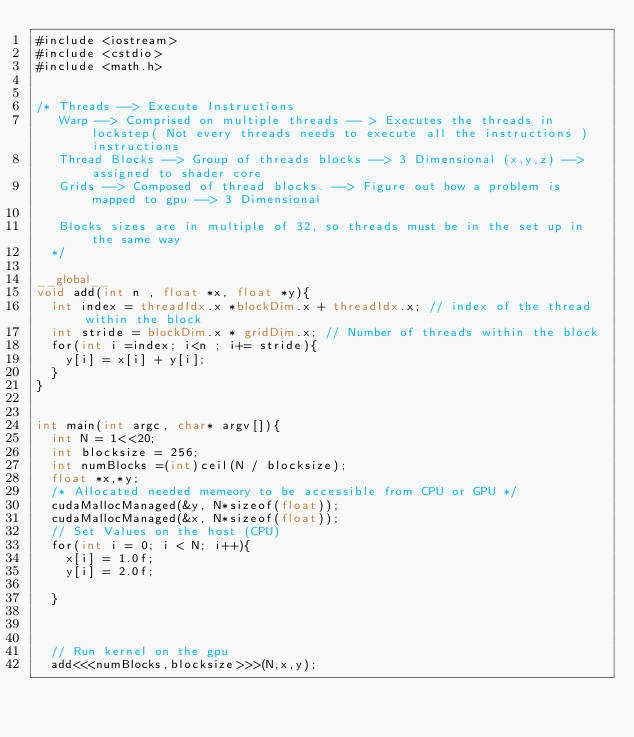Convert code to text. <code><loc_0><loc_0><loc_500><loc_500><_Cuda_>#include <iostream>
#include <cstdio>
#include <math.h>


/* Threads --> Execute Instructions
   Warp --> Comprised on multiple threads -- > Executes the threads in lockstep( Not every threads needs to execute all the instructions )instructions
   Thread Blocks --> Group of threads blocks --> 3 Dimensional (x,y,z) --> assigned to shader core
   Grids --> Composed of thread blocks. --> Figure out how a problem is mapped to gpu --> 3 Dimensional
  
   Blocks sizes are in multiple of 32, so threads must be in the set up in the same way
  */

__global__
void add(int n , float *x, float *y){
  int index = threadIdx.x *blockDim.x + threadIdx.x; // index of the thread within the block
  int stride = blockDim.x * gridDim.x; // Number of threads within the block
  for(int i =index; i<n ; i+= stride){
    y[i] = x[i] + y[i];
  }
}


int main(int argc, char* argv[]){
  int N = 1<<20;
  int blocksize = 256;
  int numBlocks =(int)ceil(N / blocksize);
  float *x,*y;
  /* Allocated needed memeory to be accessible from CPU or GPU */ 
  cudaMallocManaged(&y, N*sizeof(float));
  cudaMallocManaged(&x, N*sizeof(float));
  // Set Values on the host (CPU)
  for(int i = 0; i < N; i++){
    x[i] = 1.0f;
    y[i] = 2.0f;

  }

  

  // Run kernel on the gpu
  add<<<numBlocks,blocksize>>>(N,x,y);
</code> 